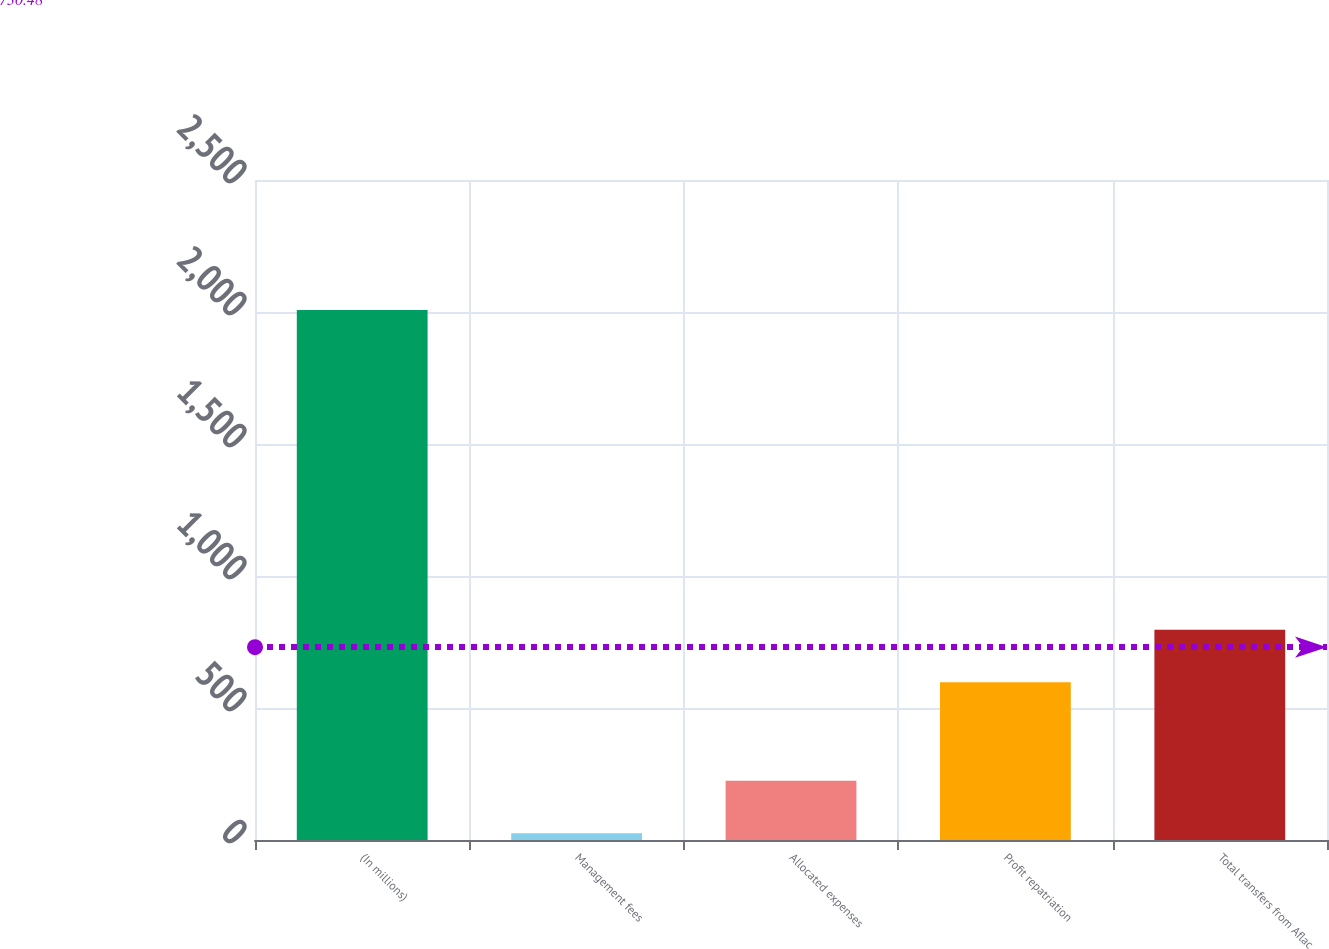<chart> <loc_0><loc_0><loc_500><loc_500><bar_chart><fcel>(In millions)<fcel>Management fees<fcel>Allocated expenses<fcel>Profit repatriation<fcel>Total transfers from Aflac<nl><fcel>2008<fcel>26<fcel>224.2<fcel>598<fcel>796.2<nl></chart> 